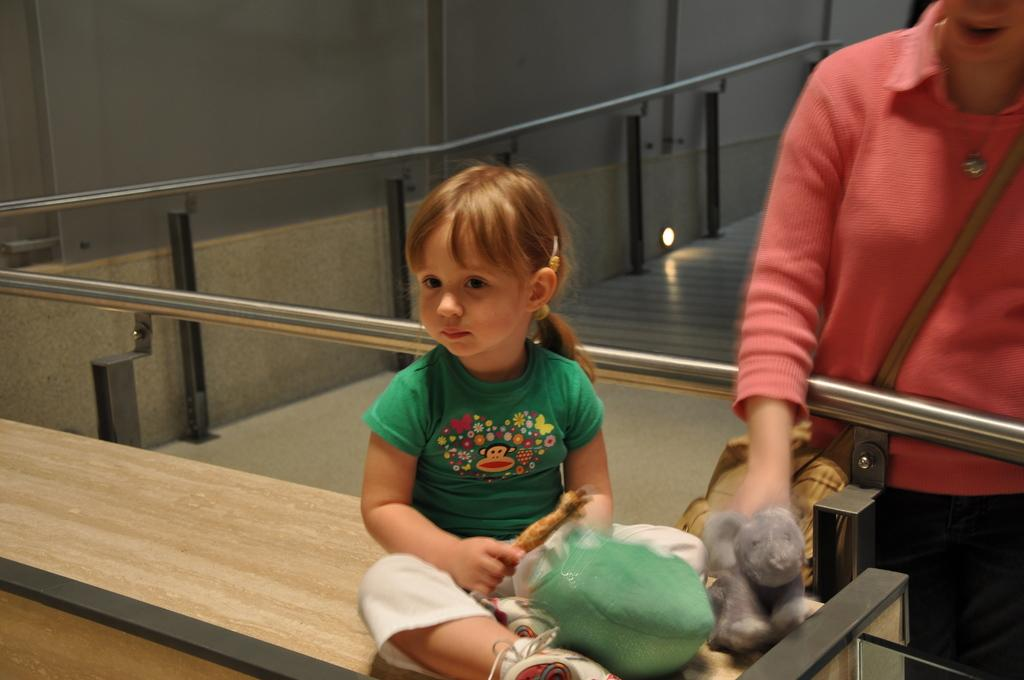What is the girl doing in the image? The girl is sitting on a surface in the image. What can be seen around the girl? There are many toys near the girl. What is the lady wearing in the image? The lady is wearing a bag in the image. What is the lady's position in the image? The lady is standing in the image. What architectural feature can be seen in the image? There is a railing in the image. Can you tell me what type of ear is visible in the image? There is no ear visible in the image. Is the seashore visible in the background of the image? The image does not depict a seashore; it features a girl sitting with toys and a lady standing with a bag. 